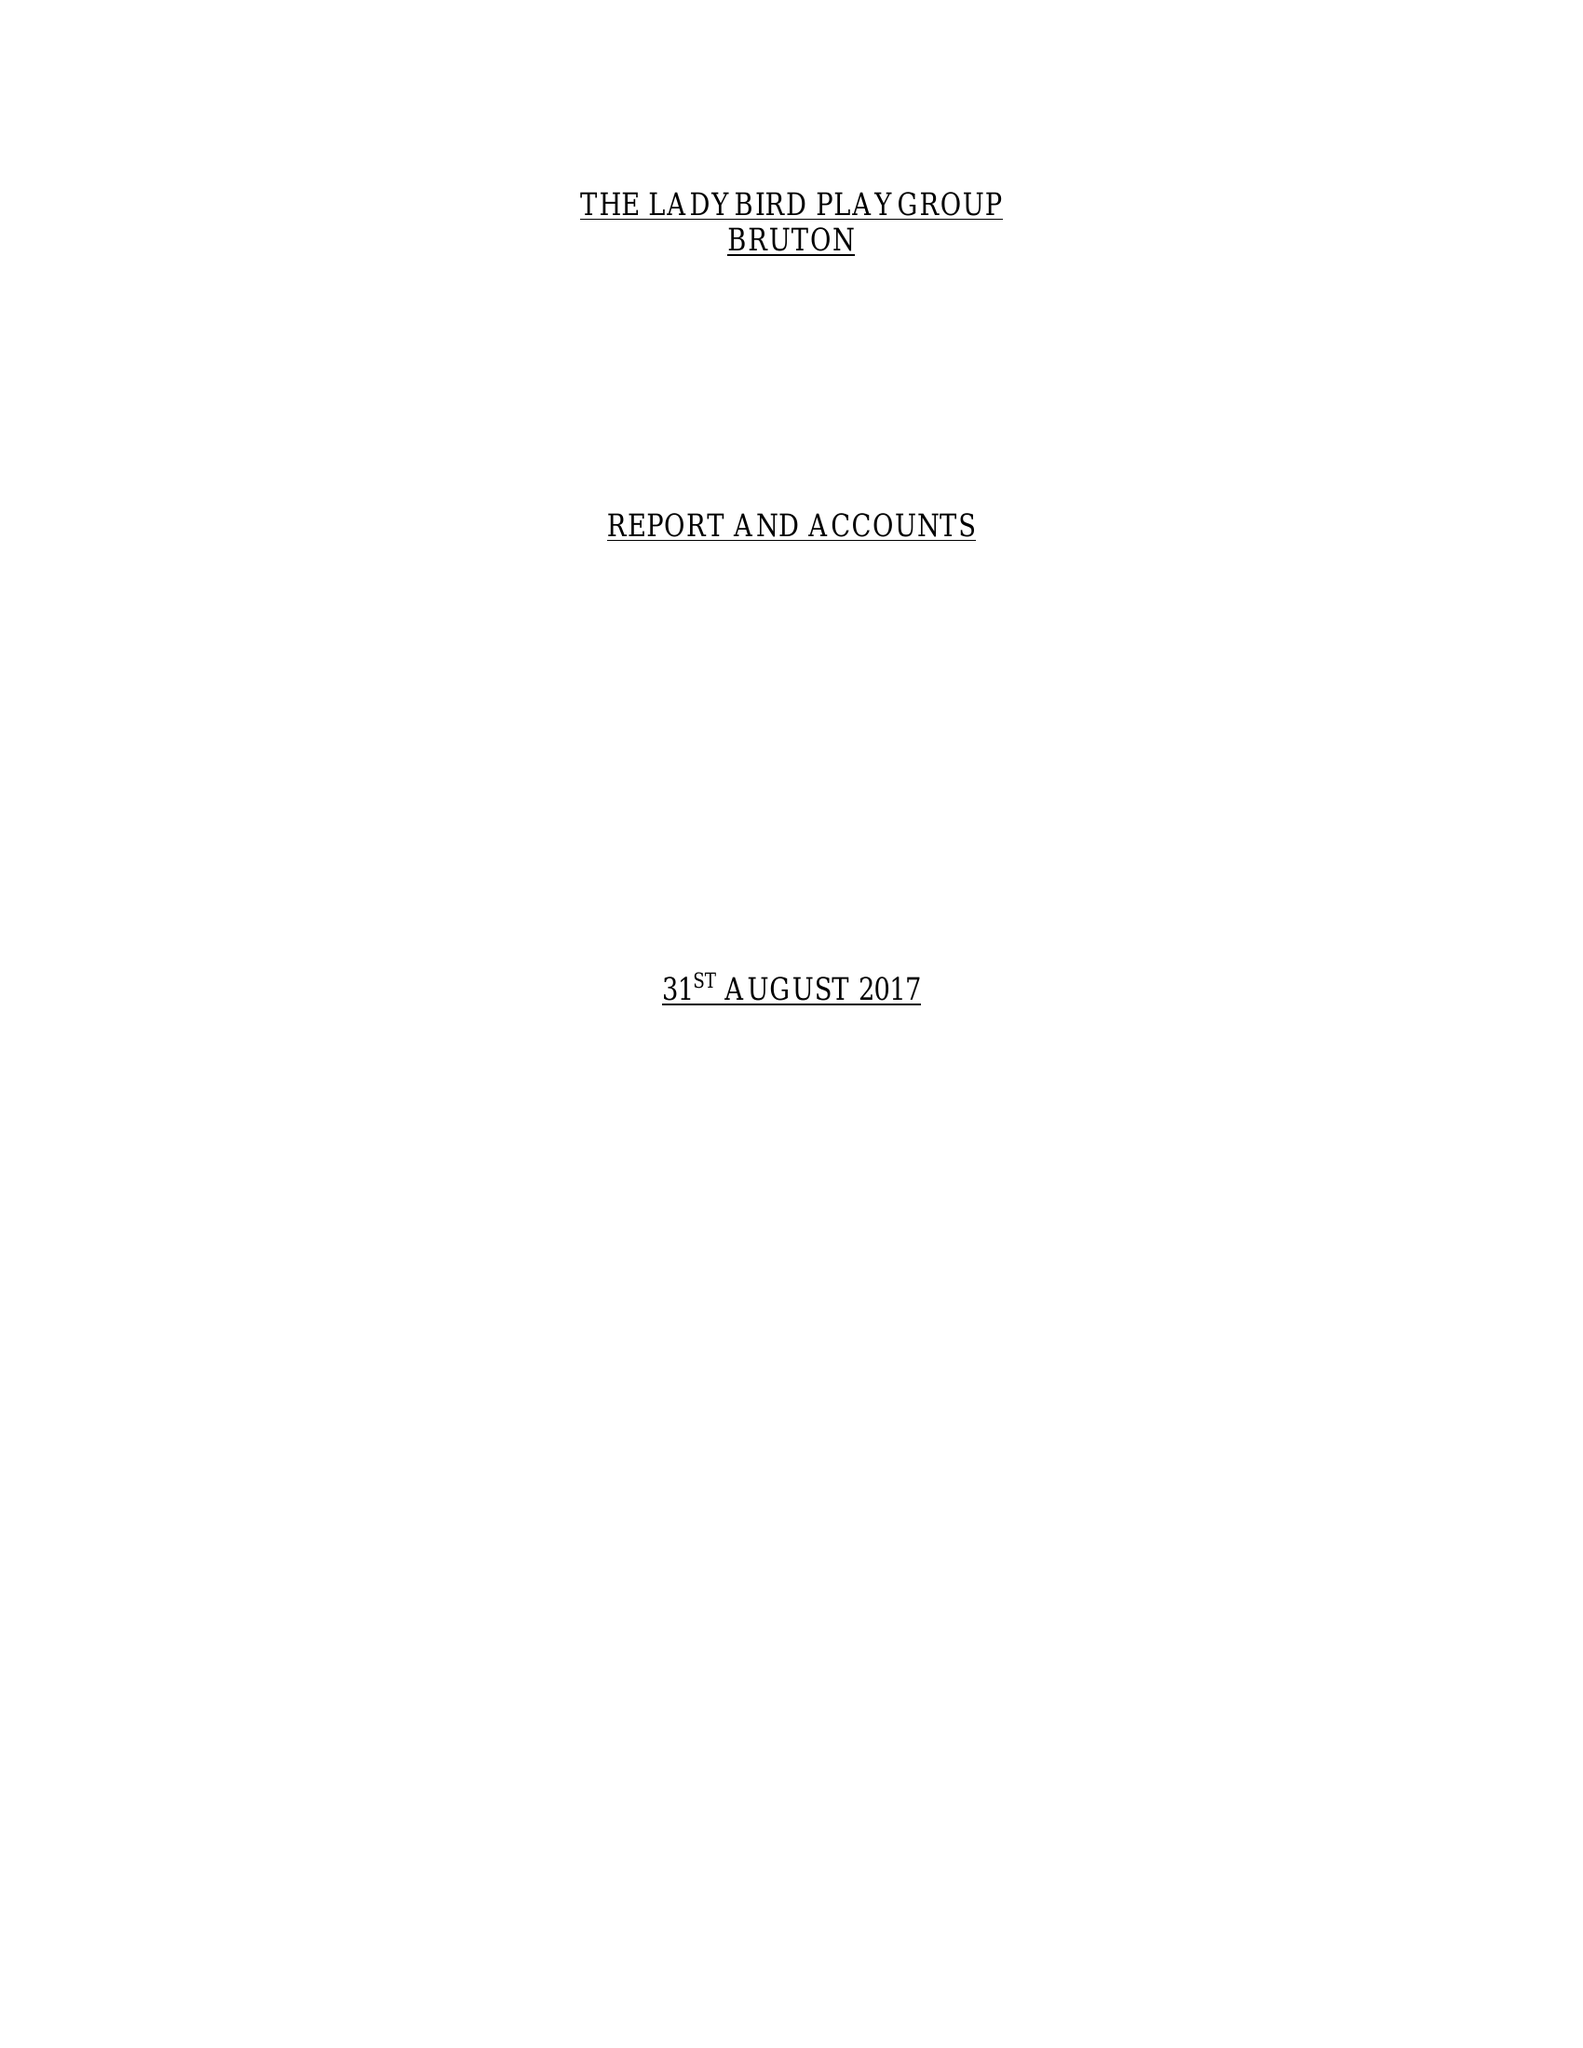What is the value for the charity_number?
Answer the question using a single word or phrase. 1038847 